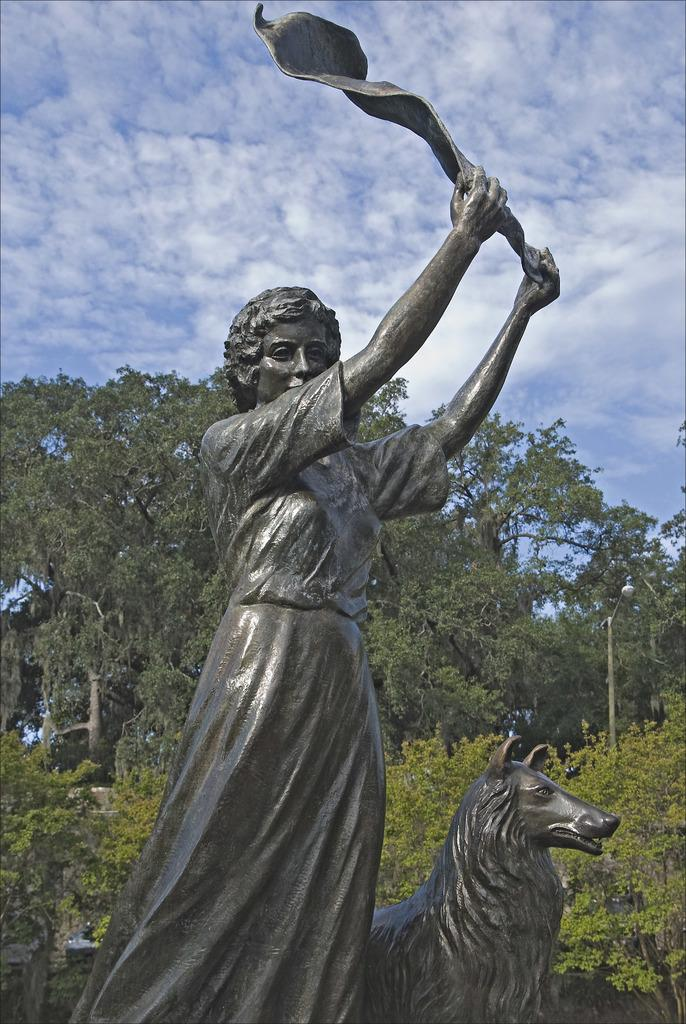What type of objects can be seen in the image? There are statues, bushes, trees, street poles, and street lights in the image. What type of vegetation is present in the image? There are bushes and trees in the image. What can be seen in the sky in the image? The sky is visible in the image, and clouds are present in the sky. What type of structures are present in the image? Street poles and street lights are present in the image. What type of drink is being served at the statue in the image? There is no drink or serving activity present in the image; it features statues, bushes, trees, street poles, and street lights. Can you hear thunder in the image? There is no sound or indication of thunder in the image; it only shows visual elements. 